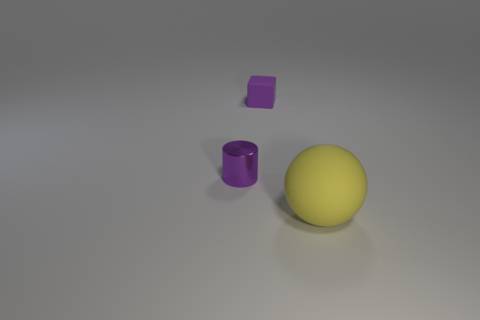The purple shiny cylinder is what size?
Offer a terse response. Small. Is the tiny block made of the same material as the large yellow object?
Offer a very short reply. Yes. There is a thing that is in front of the thing left of the purple rubber object; how many rubber spheres are left of it?
Offer a very short reply. 0. What shape is the tiny object on the right side of the tiny purple metal thing?
Provide a succinct answer. Cube. What number of other objects are there of the same material as the ball?
Give a very brief answer. 1. Does the big object have the same color as the block?
Offer a terse response. No. Is the number of rubber spheres that are behind the small purple metal thing less than the number of tiny purple metallic objects in front of the ball?
Keep it short and to the point. No. Is the size of the purple thing in front of the purple matte thing the same as the yellow matte sphere?
Offer a terse response. No. Is the number of purple cubes that are in front of the yellow rubber sphere less than the number of gray spheres?
Provide a succinct answer. No. Is there any other thing that is the same size as the metallic cylinder?
Ensure brevity in your answer.  Yes. 